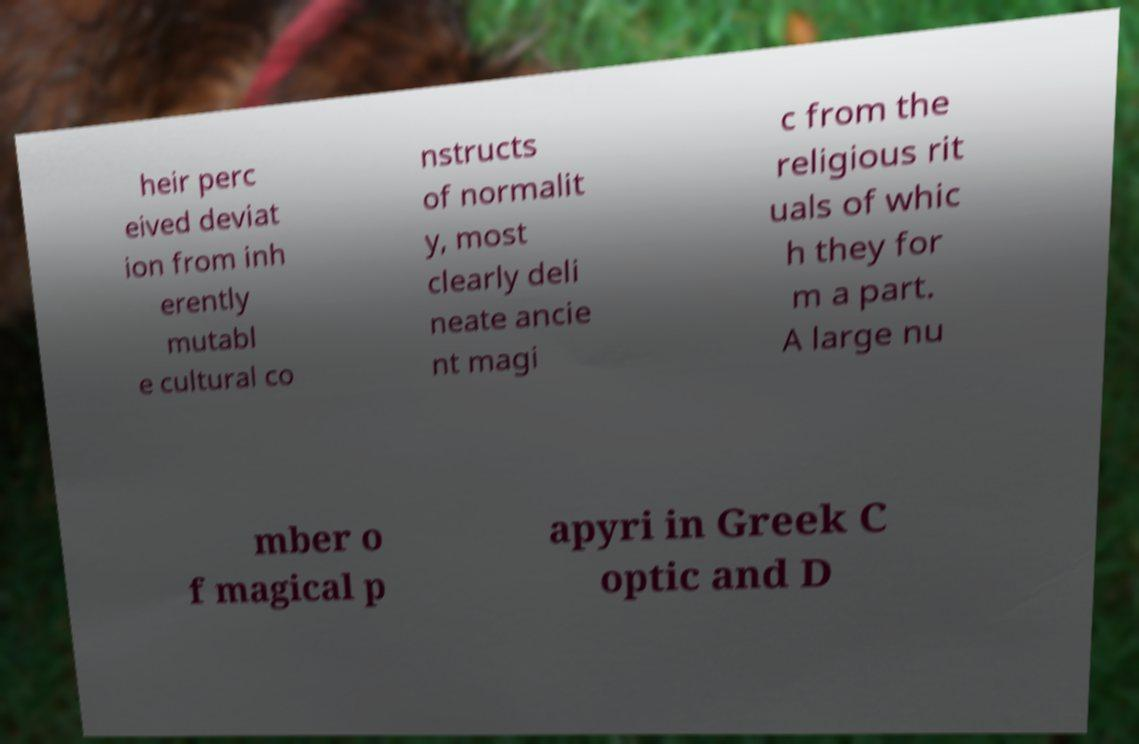Please identify and transcribe the text found in this image. heir perc eived deviat ion from inh erently mutabl e cultural co nstructs of normalit y, most clearly deli neate ancie nt magi c from the religious rit uals of whic h they for m a part. A large nu mber o f magical p apyri in Greek C optic and D 